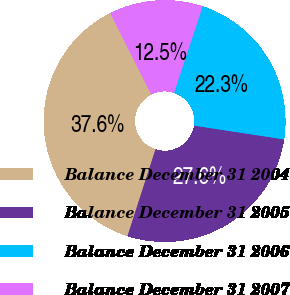<chart> <loc_0><loc_0><loc_500><loc_500><pie_chart><fcel>Balance December 31 2004<fcel>Balance December 31 2005<fcel>Balance December 31 2006<fcel>Balance December 31 2007<nl><fcel>37.59%<fcel>27.55%<fcel>22.33%<fcel>12.52%<nl></chart> 